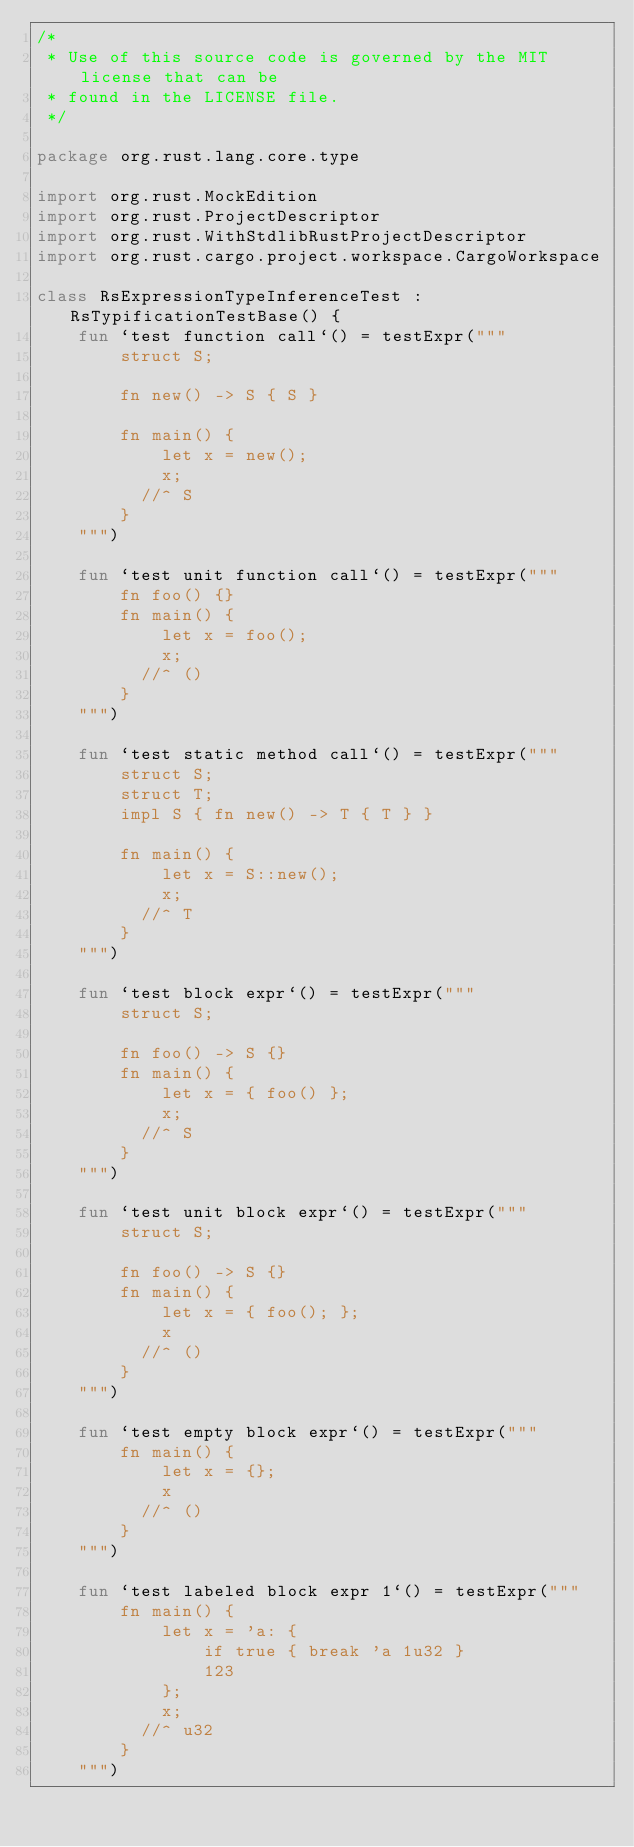Convert code to text. <code><loc_0><loc_0><loc_500><loc_500><_Kotlin_>/*
 * Use of this source code is governed by the MIT license that can be
 * found in the LICENSE file.
 */

package org.rust.lang.core.type

import org.rust.MockEdition
import org.rust.ProjectDescriptor
import org.rust.WithStdlibRustProjectDescriptor
import org.rust.cargo.project.workspace.CargoWorkspace

class RsExpressionTypeInferenceTest : RsTypificationTestBase() {
    fun `test function call`() = testExpr("""
        struct S;

        fn new() -> S { S }

        fn main() {
            let x = new();
            x;
          //^ S
        }
    """)

    fun `test unit function call`() = testExpr("""
        fn foo() {}
        fn main() {
            let x = foo();
            x;
          //^ ()
        }
    """)

    fun `test static method call`() = testExpr("""
        struct S;
        struct T;
        impl S { fn new() -> T { T } }

        fn main() {
            let x = S::new();
            x;
          //^ T
        }
    """)

    fun `test block expr`() = testExpr("""
        struct S;

        fn foo() -> S {}
        fn main() {
            let x = { foo() };
            x;
          //^ S
        }
    """)

    fun `test unit block expr`() = testExpr("""
        struct S;

        fn foo() -> S {}
        fn main() {
            let x = { foo(); };
            x
          //^ ()
        }
    """)

    fun `test empty block expr`() = testExpr("""
        fn main() {
            let x = {};
            x
          //^ ()
        }
    """)

    fun `test labeled block expr 1`() = testExpr("""
        fn main() {
            let x = 'a: {
                if true { break 'a 1u32 }
                123
            };
            x;
          //^ u32
        }
    """)
</code> 